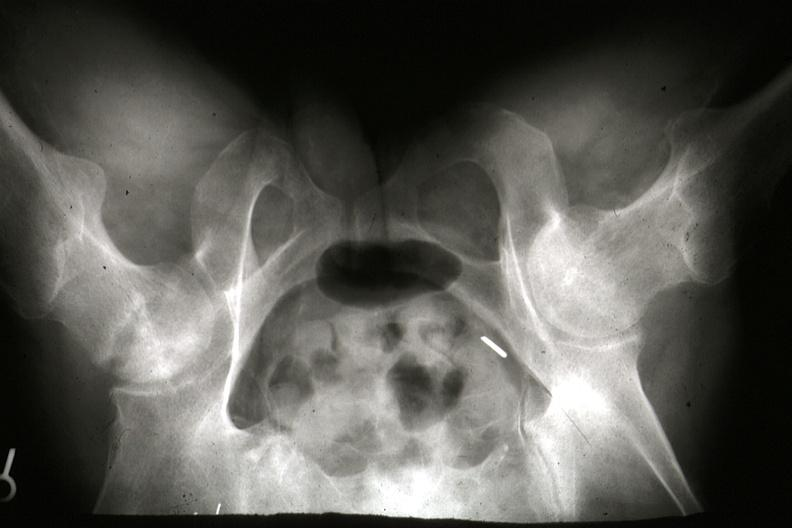what are 7182 and 7183 lesion?
Answer the question using a single word or phrase. Gross postmortx-rays of this 